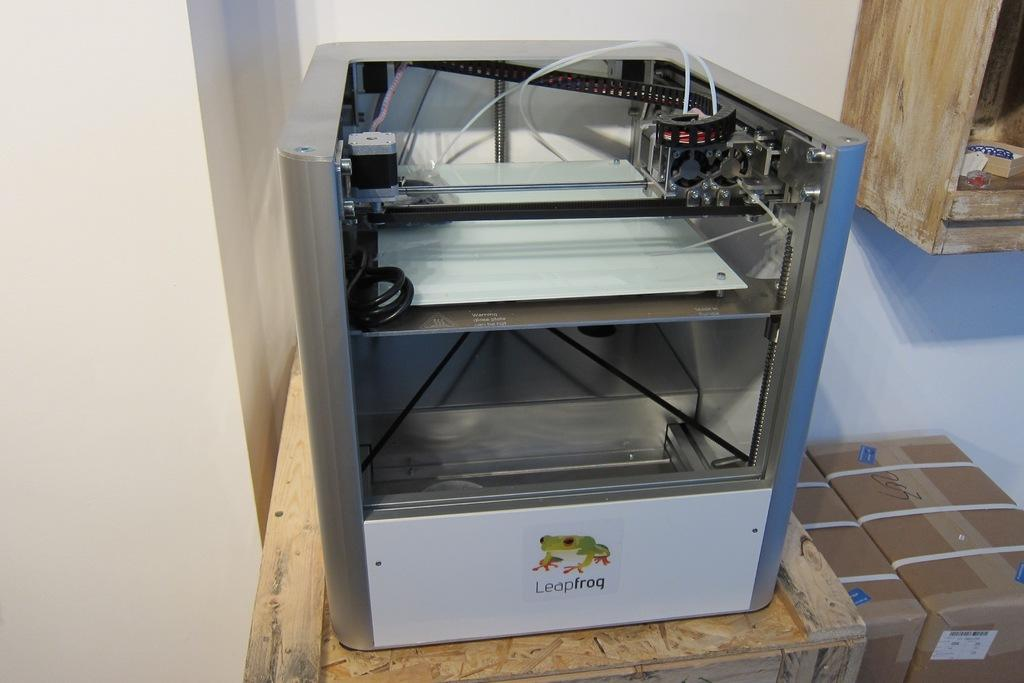<image>
Offer a succinct explanation of the picture presented. a metal item with the word leap frog on it 